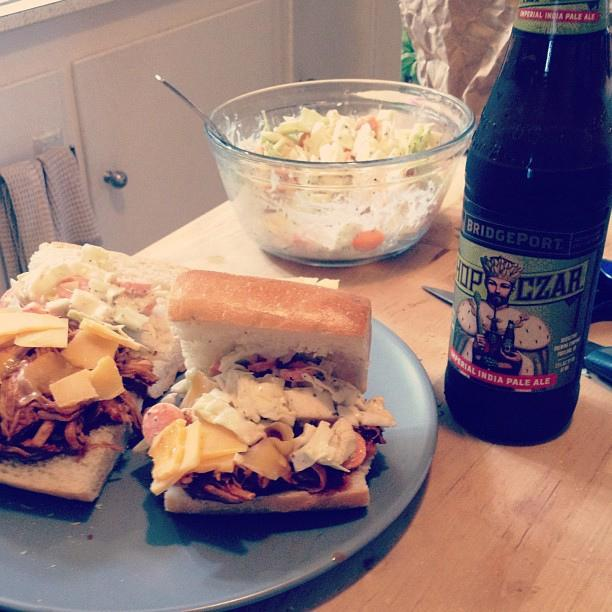Where was this food made? Please explain your reasoning. home. Because the food id served in a ordinary plate. 